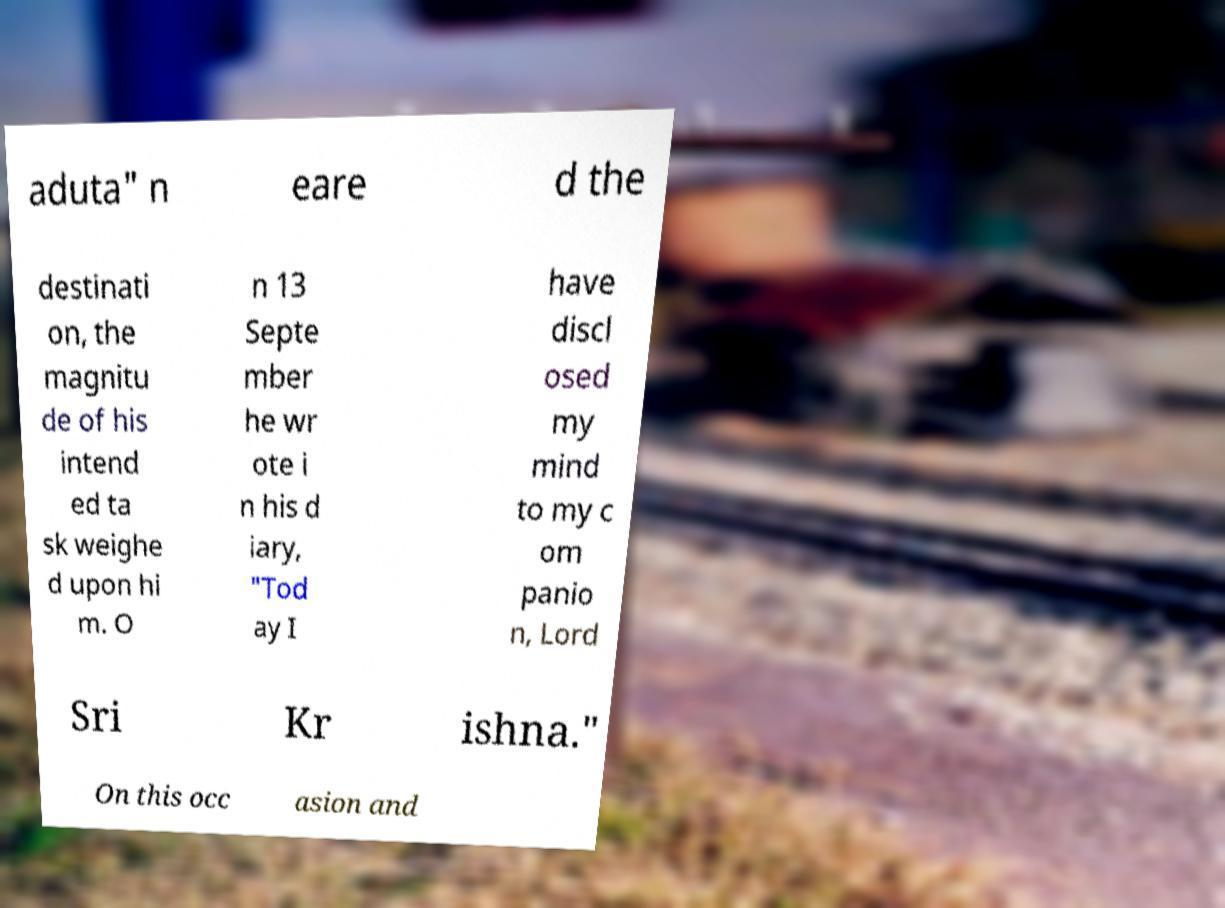There's text embedded in this image that I need extracted. Can you transcribe it verbatim? aduta" n eare d the destinati on, the magnitu de of his intend ed ta sk weighe d upon hi m. O n 13 Septe mber he wr ote i n his d iary, "Tod ay I have discl osed my mind to my c om panio n, Lord Sri Kr ishna." On this occ asion and 